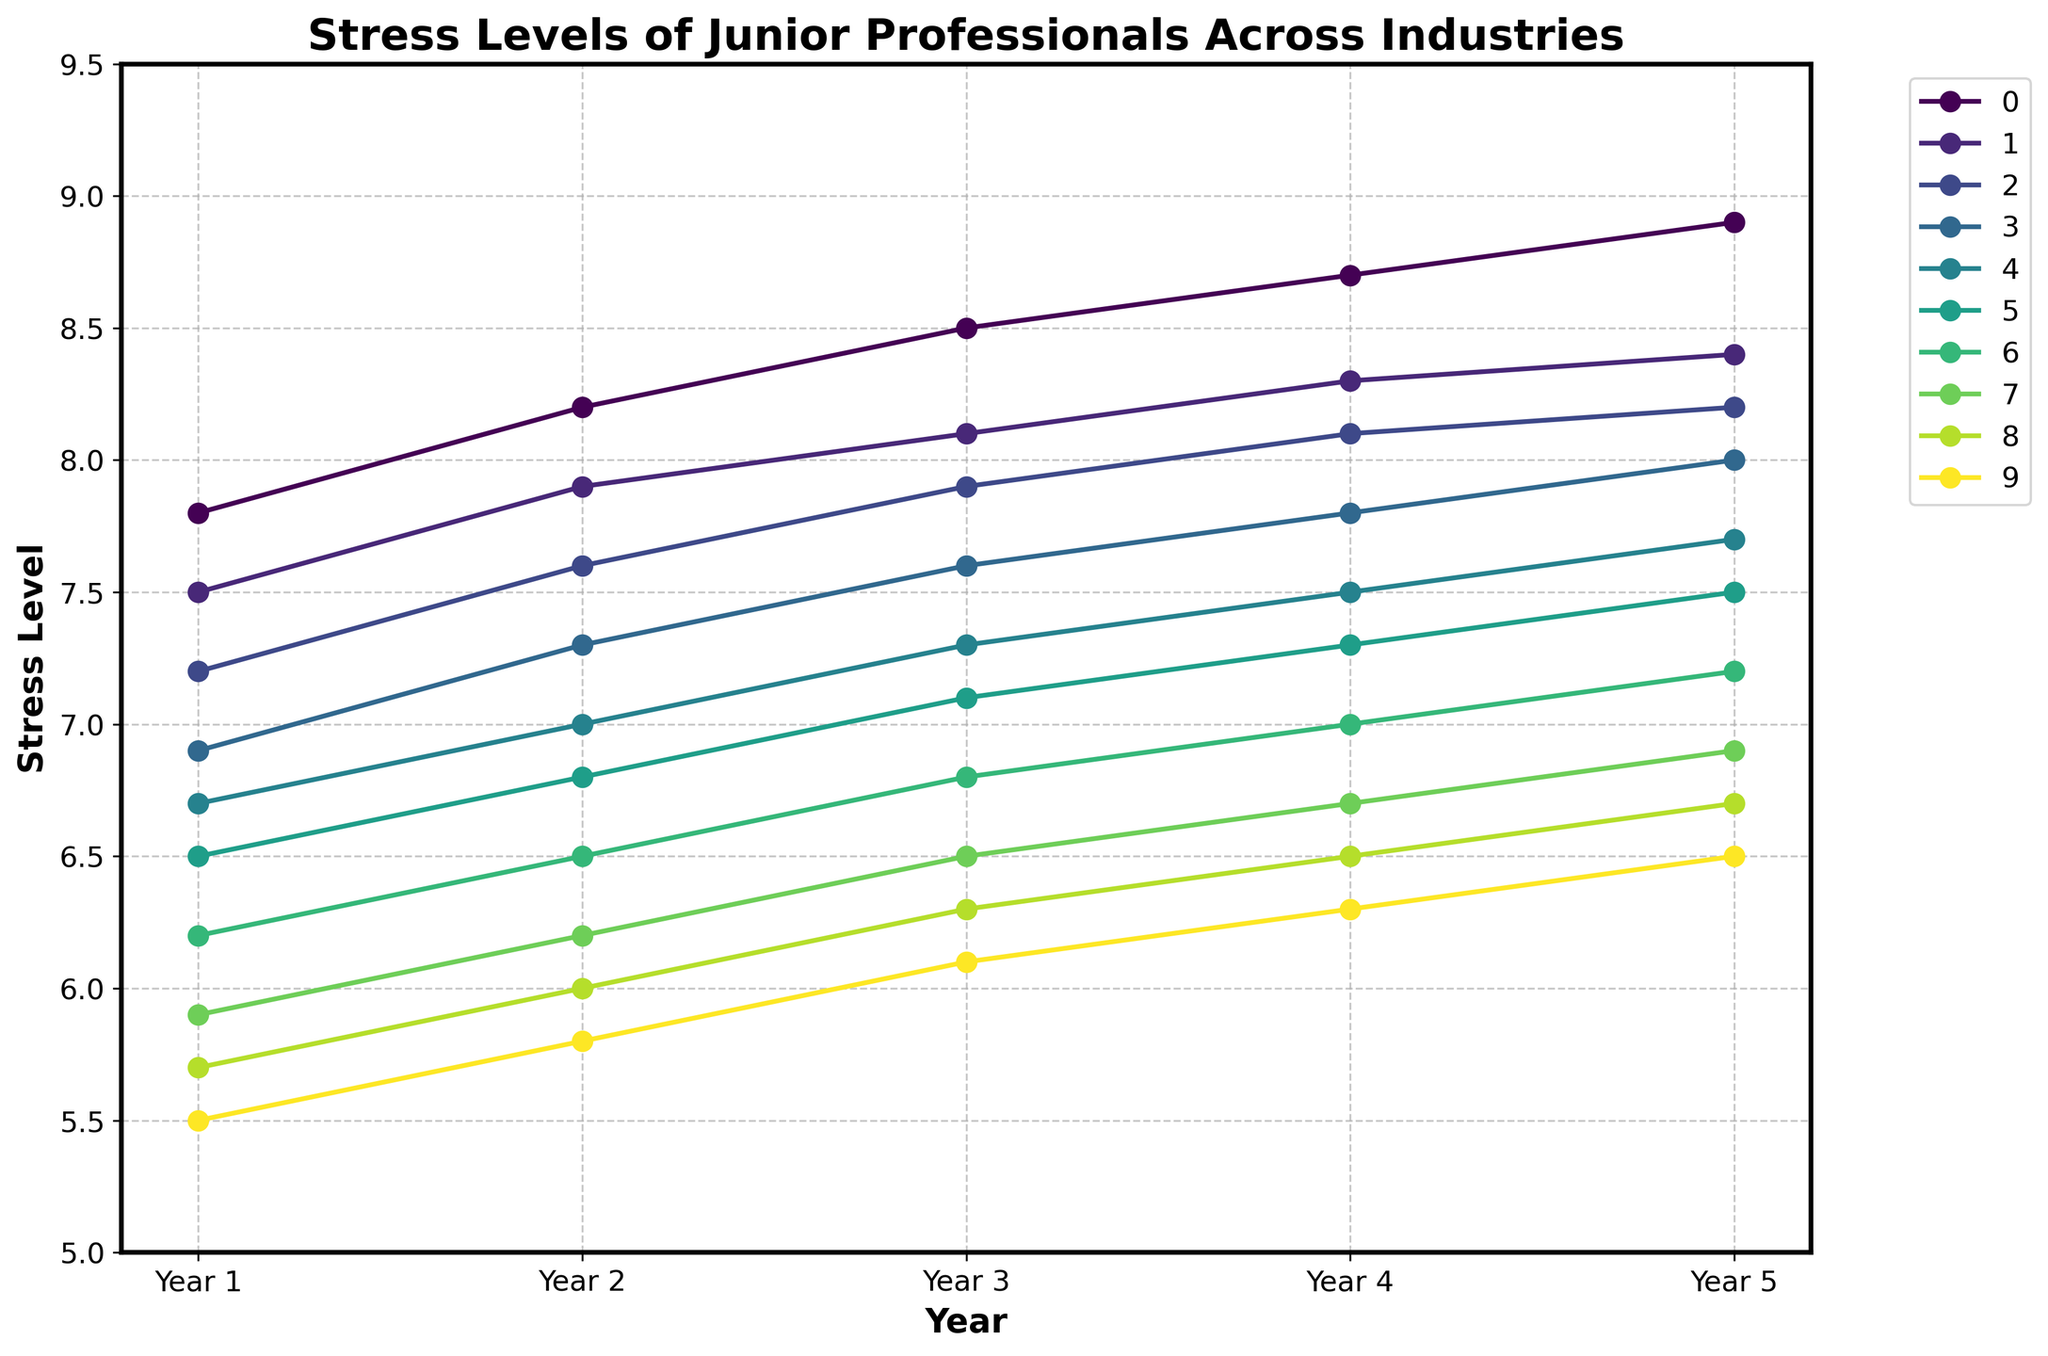What's the industry with the highest initial stress level in Year 1? In Year 1, the plot shows the highest value at the beginning of the Investment Banking line (7.8).
Answer: Investment Banking What's the industry with the greatest overall increase in stress level from Year 1 to Year 5? Calculate the difference in stress levels between Year 1 and Year 5 for each industry. The largest increase is recorded by Investment Banking, which starts at 7.8 and ends at 8.9 (+1.1).
Answer: Investment Banking Which industry had the least increase in stress levels from Year 1 to Year 5? Calculate the difference for each industry. Hospitality increased from 5.5 to 6.5, which is the smallest change (+1.0).
Answer: Hospitality During Year 3, which industry had the highest stress level? Look at the plot for Year 3 and identify the highest point; it is Investment Banking with an 8.5 stress level.
Answer: Investment Banking How did the stress level in the Tech Startups industry compare to the Advertising industry in Year 4? In Year 4, Tech Startups has a stress level of 7.8 while Advertising has 7.5, so Tech Startups is higher by 0.3.
Answer: Tech Startups was higher by 0.3 Comparing Year 1 and Year 3, which industry showed the largest increase in stress level? Calculate the increase by subtracting Year 1 from Year 3 for each industry. Investment Banking has the largest increase from 7.8 to 8.5 (+0.7).
Answer: Investment Banking What's the average stress level of the Healthcare industry across all 5 years? Sum Healthcare's yearly stress levels (6.5 + 6.8 + 7.1 + 7.3 + 7.5 = 35.2) and divide by 5 (35.2 / 5 = 7.04).
Answer: 7.04 Which industry had the lowest stress level in Year 5? Look at the values for Year 5 on the plot, the lowest point is Hospitality with a stress level of 6.5.
Answer: Hospitality What is the difference in stress levels between Education and Non-profit industries in Year 2? In Year 2, Education is 6.5 and Non-profit is 6.2. The difference is 0.3 (6.5 - 6.2).
Answer: 0.3 Which industries had a stress level that surpassed 8.0 in any given year? Check each line for values above 8.0. Investment Banking, Management Consulting, Law, and Tech Startups all surpass 8.0 in various years.
Answer: Investment Banking, Management Consulting, Law, Tech Startups 